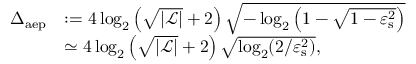<formula> <loc_0><loc_0><loc_500><loc_500>\begin{array} { r l } { \Delta _ { a e p } } & { \colon = 4 \log _ { 2 } \left ( \sqrt { | \mathcal { L } | } + 2 \right ) \sqrt { - \log _ { 2 } \left ( 1 - \sqrt { 1 - \varepsilon _ { s } ^ { 2 } } \right ) } } \\ & { \simeq 4 \log _ { 2 } \left ( \sqrt { | \mathcal { L } | } + 2 \right ) \sqrt { \log _ { 2 } ( 2 / \varepsilon _ { s } ^ { 2 } ) } , } \end{array}</formula> 